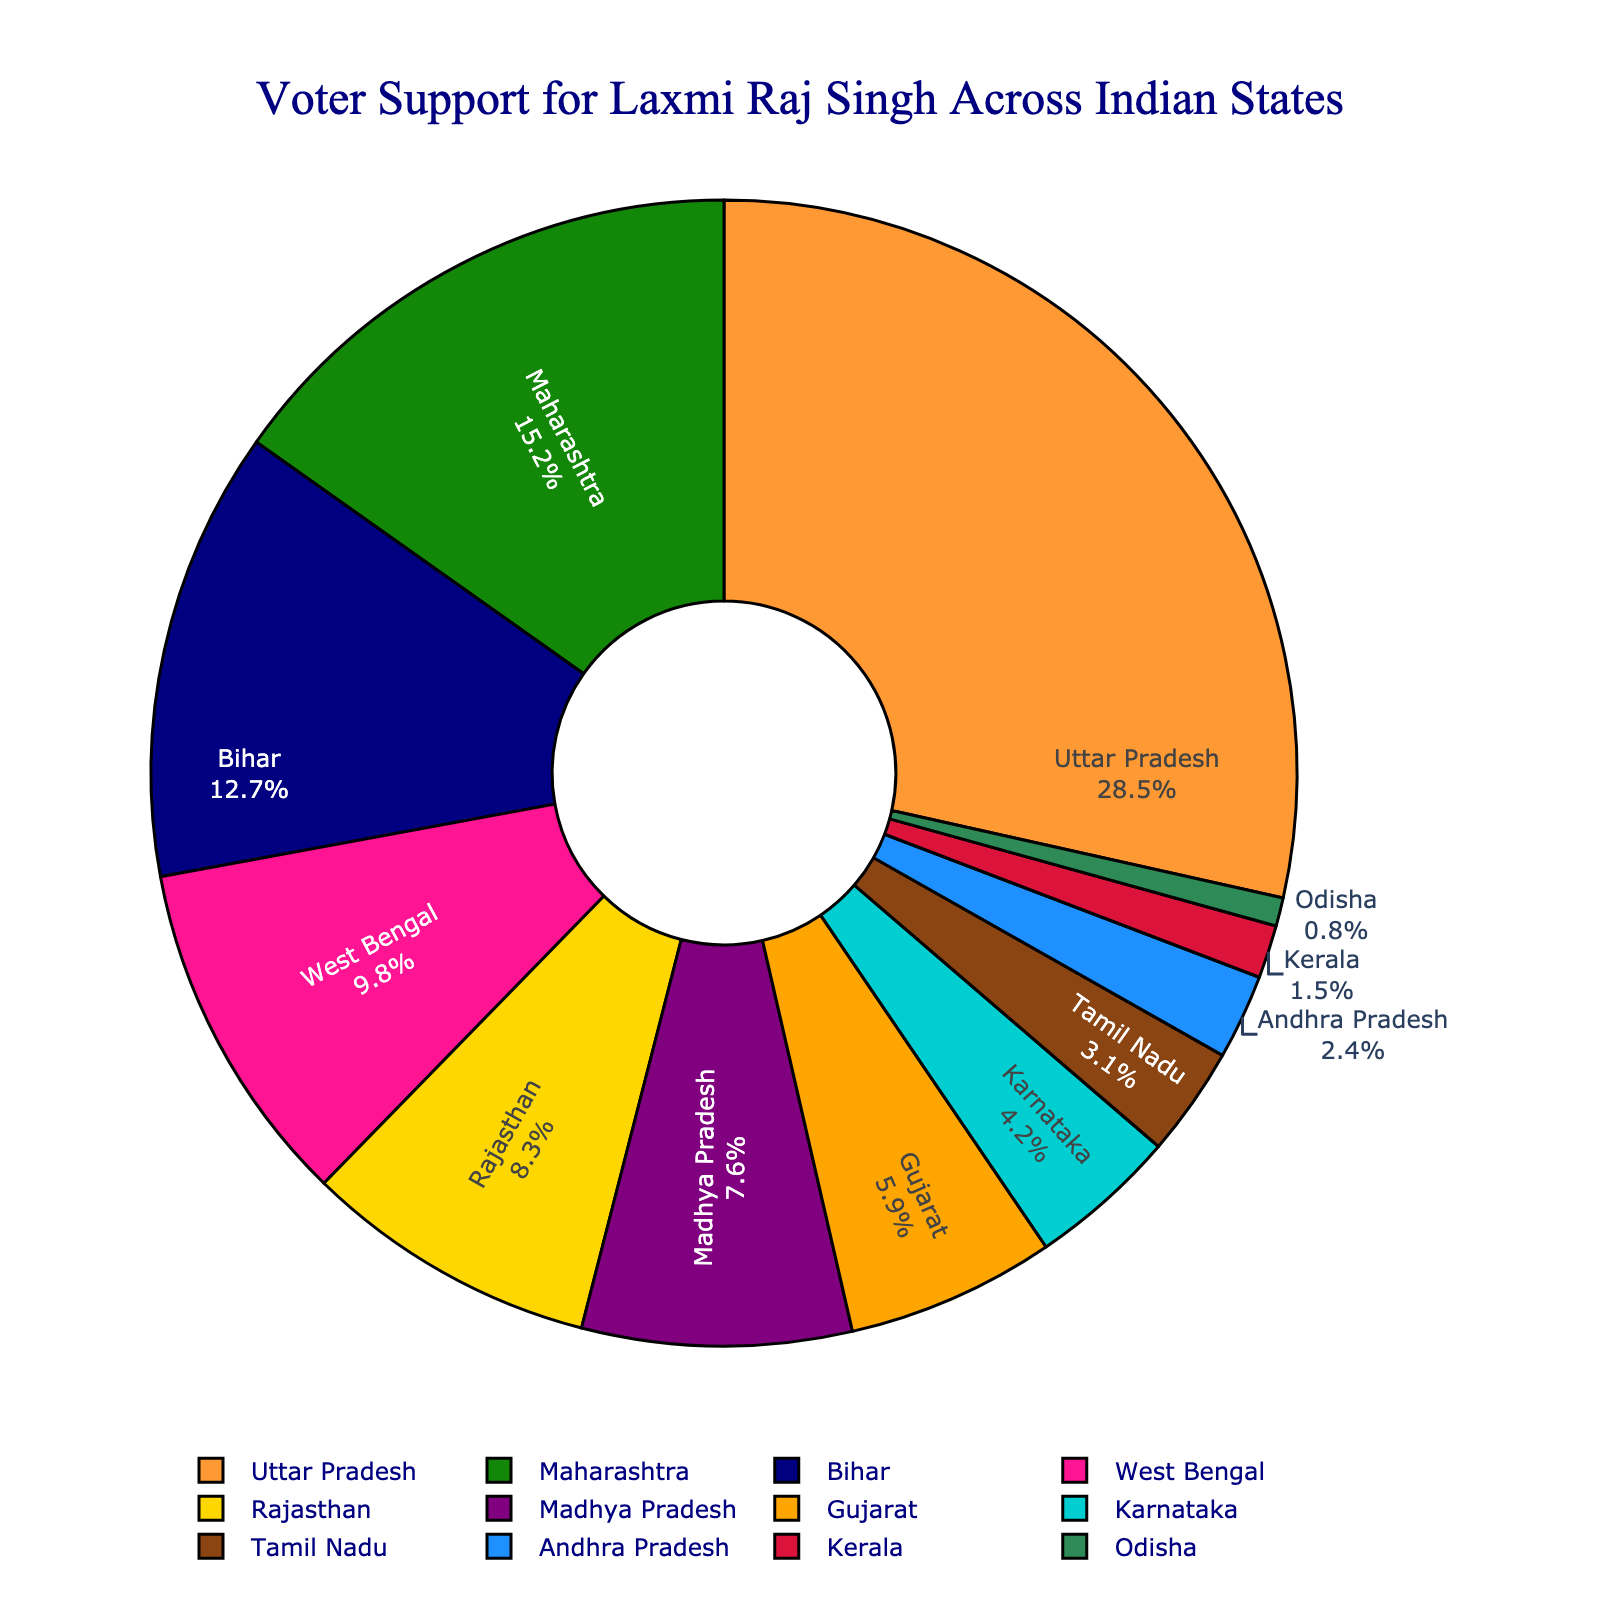Which state has the highest voter support for Laxmi Raj Singh? To find the state with the highest voter support, look at the value that occupies the largest segment in the pie chart. Uttar Pradesh is labeled with 28.5%, which is the highest percentage shown.
Answer: Uttar Pradesh Which state has less voter support, Karnataka or Tamil Nadu? Compare the voter support percentages for Karnataka (4.2%) and Tamil Nadu (3.1%) directly from the chart. Since 4.2% is greater than 3.1%, Tamil Nadu has less voter support than Karnataka.
Answer: Tamil Nadu What is the total voter support percentage from Bihar and West Bengal combined? Add the voter support percentages for Bihar (12.7%) and West Bengal (9.8%) together. 12.7% + 9.8% = 22.5%.
Answer: 22.5% Which state provides more voter support for Laxmi Raj Singh: Gujarat or Madhya Pradesh? Compare the voter support percentages for Gujarat (5.9%) and Madhya Pradesh (7.6%). Since 7.6% is greater than 5.9%, Madhya Pradesh provides more voter support.
Answer: Madhya Pradesh What is the difference in voter support percentages between Maharashtra and Rajasthan? Subtract the voter support percentage of Rajasthan (8.3%) from Maharashtra (15.2%). 15.2% - 8.3% = 6.9%.
Answer: 6.9% Which states have less than 5% voter support? Identify states in the pie chart with less than 5% voter support: Karnataka (4.2%), Tamil Nadu (3.1%), Andhra Pradesh (2.4%), Kerala (1.5%), Odisha (0.8%).
Answer: Karnataka, Tamil Nadu, Andhra Pradesh, Kerala, Odisha What is the average voter support percentage for the states of Uttar Pradesh, Bihar, and Gujarat? Add the percentages for Uttar Pradesh (28.5%), Bihar (12.7%), and Gujarat (5.9%) and then divide by 3. (28.5% + 12.7% + 5.9%) / 3 = 47.1% / 3 = 15.7%.
Answer: 15.7% What percentage of total voter support comes from Uttar Pradesh, Maharashtra, and Bihar combined? Add the percentages of Uttar Pradesh (28.5%), Maharashtra (15.2%), and Bihar (12.7%). 28.5% + 15.2% + 12.7% = 56.4%.
Answer: 56.4% How many states have voter support percentages between 5% and 10%? Identify states with voter support percentages in this range: West Bengal (9.8%), Rajasthan (8.3%), Madhya Pradesh (7.6%), Gujarat (5.9%). There are 4 such states.
Answer: 4 Which state has the smallest voter support, and what is its percentage? Look at the pie chart and find the segment with the smallest voter support percentage, which is Odisha at 0.8%.
Answer: Odisha, 0.8% 